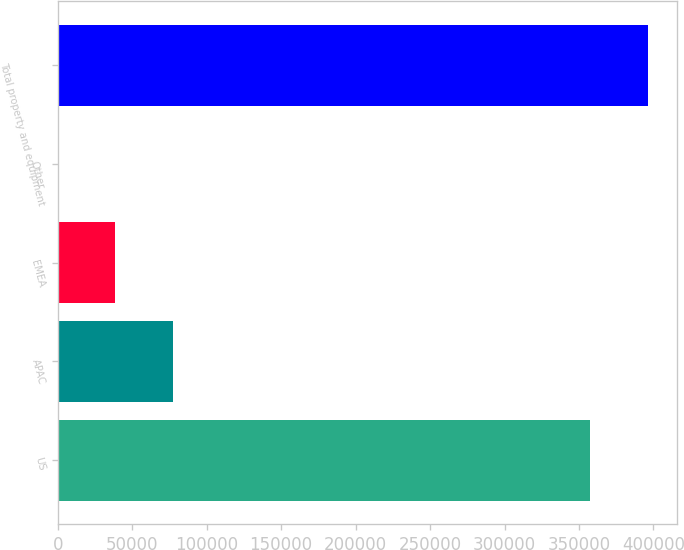Convert chart to OTSL. <chart><loc_0><loc_0><loc_500><loc_500><bar_chart><fcel>US<fcel>APAC<fcel>EMEA<fcel>Other<fcel>Total property and equipment<nl><fcel>357607<fcel>77122.8<fcel>38575.9<fcel>29<fcel>396154<nl></chart> 